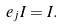<formula> <loc_0><loc_0><loc_500><loc_500>e _ { j } I = I .</formula> 